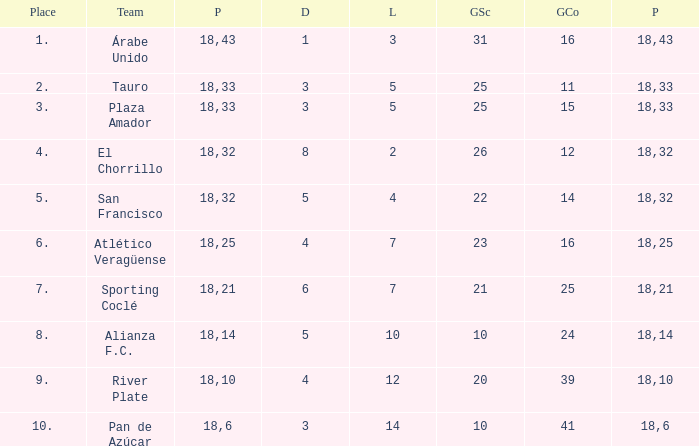How many goals were conceded by the team with more than 21 points more than 5 draws and less than 18 games played? None. 